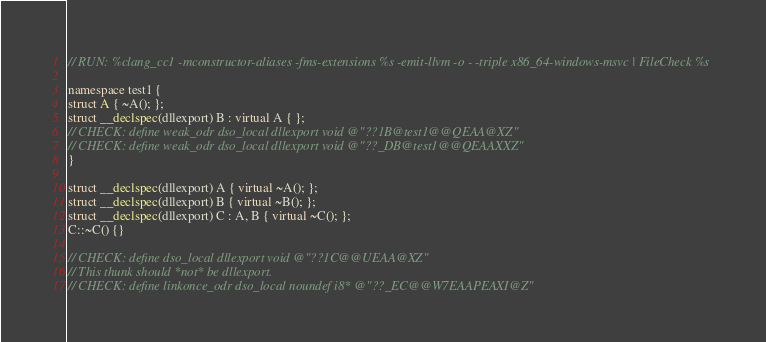<code> <loc_0><loc_0><loc_500><loc_500><_C++_>// RUN: %clang_cc1 -mconstructor-aliases -fms-extensions %s -emit-llvm -o - -triple x86_64-windows-msvc | FileCheck %s

namespace test1 {
struct A { ~A(); };
struct __declspec(dllexport) B : virtual A { };
// CHECK: define weak_odr dso_local dllexport void @"??1B@test1@@QEAA@XZ"
// CHECK: define weak_odr dso_local dllexport void @"??_DB@test1@@QEAAXXZ"
}

struct __declspec(dllexport) A { virtual ~A(); };
struct __declspec(dllexport) B { virtual ~B(); };
struct __declspec(dllexport) C : A, B { virtual ~C(); };
C::~C() {}

// CHECK: define dso_local dllexport void @"??1C@@UEAA@XZ"
// This thunk should *not* be dllexport.
// CHECK: define linkonce_odr dso_local noundef i8* @"??_EC@@W7EAAPEAXI@Z"
</code> 